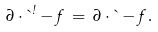Convert formula to latex. <formula><loc_0><loc_0><loc_500><loc_500>\partial \cdot \theta ^ { \omega } - f \, = \, \partial \cdot \theta - f \, .</formula> 